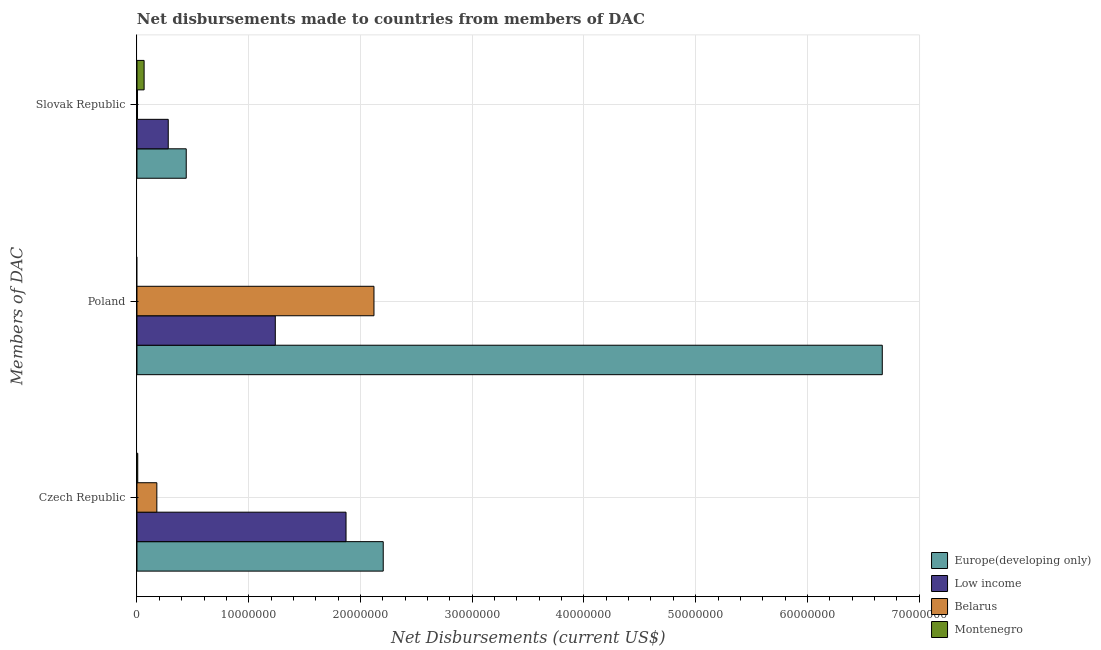How many different coloured bars are there?
Your answer should be compact. 4. Are the number of bars on each tick of the Y-axis equal?
Your answer should be very brief. No. How many bars are there on the 1st tick from the top?
Offer a terse response. 4. How many bars are there on the 3rd tick from the bottom?
Offer a very short reply. 4. What is the net disbursements made by slovak republic in Low income?
Offer a very short reply. 2.80e+06. Across all countries, what is the maximum net disbursements made by poland?
Your answer should be compact. 6.67e+07. In which country was the net disbursements made by poland maximum?
Your response must be concise. Europe(developing only). What is the total net disbursements made by poland in the graph?
Offer a very short reply. 1.00e+08. What is the difference between the net disbursements made by czech republic in Montenegro and that in Low income?
Your answer should be compact. -1.86e+07. What is the difference between the net disbursements made by slovak republic in Montenegro and the net disbursements made by poland in Europe(developing only)?
Make the answer very short. -6.61e+07. What is the average net disbursements made by slovak republic per country?
Give a very brief answer. 1.98e+06. What is the difference between the net disbursements made by poland and net disbursements made by czech republic in Belarus?
Keep it short and to the point. 1.94e+07. What is the ratio of the net disbursements made by slovak republic in Belarus to that in Europe(developing only)?
Ensure brevity in your answer.  0.01. Is the difference between the net disbursements made by czech republic in Low income and Europe(developing only) greater than the difference between the net disbursements made by poland in Low income and Europe(developing only)?
Your answer should be very brief. Yes. What is the difference between the highest and the second highest net disbursements made by slovak republic?
Make the answer very short. 1.61e+06. What is the difference between the highest and the lowest net disbursements made by poland?
Your response must be concise. 6.67e+07. Is it the case that in every country, the sum of the net disbursements made by czech republic and net disbursements made by poland is greater than the net disbursements made by slovak republic?
Your response must be concise. No. How many bars are there?
Make the answer very short. 11. Are all the bars in the graph horizontal?
Your response must be concise. Yes. Are the values on the major ticks of X-axis written in scientific E-notation?
Offer a terse response. No. Does the graph contain any zero values?
Provide a succinct answer. Yes. What is the title of the graph?
Make the answer very short. Net disbursements made to countries from members of DAC. Does "Cabo Verde" appear as one of the legend labels in the graph?
Provide a succinct answer. No. What is the label or title of the X-axis?
Keep it short and to the point. Net Disbursements (current US$). What is the label or title of the Y-axis?
Provide a succinct answer. Members of DAC. What is the Net Disbursements (current US$) in Europe(developing only) in Czech Republic?
Ensure brevity in your answer.  2.20e+07. What is the Net Disbursements (current US$) of Low income in Czech Republic?
Give a very brief answer. 1.87e+07. What is the Net Disbursements (current US$) of Belarus in Czech Republic?
Offer a terse response. 1.78e+06. What is the Net Disbursements (current US$) in Europe(developing only) in Poland?
Your answer should be very brief. 6.67e+07. What is the Net Disbursements (current US$) of Low income in Poland?
Provide a succinct answer. 1.24e+07. What is the Net Disbursements (current US$) of Belarus in Poland?
Your answer should be compact. 2.12e+07. What is the Net Disbursements (current US$) in Europe(developing only) in Slovak Republic?
Make the answer very short. 4.41e+06. What is the Net Disbursements (current US$) in Low income in Slovak Republic?
Ensure brevity in your answer.  2.80e+06. What is the Net Disbursements (current US$) in Belarus in Slovak Republic?
Ensure brevity in your answer.  5.00e+04. What is the Net Disbursements (current US$) in Montenegro in Slovak Republic?
Give a very brief answer. 6.40e+05. Across all Members of DAC, what is the maximum Net Disbursements (current US$) of Europe(developing only)?
Make the answer very short. 6.67e+07. Across all Members of DAC, what is the maximum Net Disbursements (current US$) in Low income?
Your response must be concise. 1.87e+07. Across all Members of DAC, what is the maximum Net Disbursements (current US$) of Belarus?
Offer a very short reply. 2.12e+07. Across all Members of DAC, what is the maximum Net Disbursements (current US$) of Montenegro?
Ensure brevity in your answer.  6.40e+05. Across all Members of DAC, what is the minimum Net Disbursements (current US$) of Europe(developing only)?
Provide a succinct answer. 4.41e+06. Across all Members of DAC, what is the minimum Net Disbursements (current US$) in Low income?
Offer a very short reply. 2.80e+06. Across all Members of DAC, what is the minimum Net Disbursements (current US$) in Montenegro?
Offer a terse response. 0. What is the total Net Disbursements (current US$) in Europe(developing only) in the graph?
Offer a very short reply. 9.32e+07. What is the total Net Disbursements (current US$) in Low income in the graph?
Your answer should be compact. 3.39e+07. What is the total Net Disbursements (current US$) in Belarus in the graph?
Your answer should be compact. 2.30e+07. What is the total Net Disbursements (current US$) in Montenegro in the graph?
Your answer should be very brief. 7.10e+05. What is the difference between the Net Disbursements (current US$) in Europe(developing only) in Czech Republic and that in Poland?
Provide a succinct answer. -4.47e+07. What is the difference between the Net Disbursements (current US$) in Low income in Czech Republic and that in Poland?
Offer a terse response. 6.33e+06. What is the difference between the Net Disbursements (current US$) of Belarus in Czech Republic and that in Poland?
Your answer should be compact. -1.94e+07. What is the difference between the Net Disbursements (current US$) in Europe(developing only) in Czech Republic and that in Slovak Republic?
Provide a succinct answer. 1.76e+07. What is the difference between the Net Disbursements (current US$) of Low income in Czech Republic and that in Slovak Republic?
Keep it short and to the point. 1.59e+07. What is the difference between the Net Disbursements (current US$) in Belarus in Czech Republic and that in Slovak Republic?
Your response must be concise. 1.73e+06. What is the difference between the Net Disbursements (current US$) of Montenegro in Czech Republic and that in Slovak Republic?
Your answer should be compact. -5.70e+05. What is the difference between the Net Disbursements (current US$) of Europe(developing only) in Poland and that in Slovak Republic?
Your answer should be compact. 6.23e+07. What is the difference between the Net Disbursements (current US$) of Low income in Poland and that in Slovak Republic?
Provide a short and direct response. 9.58e+06. What is the difference between the Net Disbursements (current US$) in Belarus in Poland and that in Slovak Republic?
Offer a very short reply. 2.12e+07. What is the difference between the Net Disbursements (current US$) in Europe(developing only) in Czech Republic and the Net Disbursements (current US$) in Low income in Poland?
Your answer should be compact. 9.66e+06. What is the difference between the Net Disbursements (current US$) in Europe(developing only) in Czech Republic and the Net Disbursements (current US$) in Belarus in Poland?
Provide a short and direct response. 8.30e+05. What is the difference between the Net Disbursements (current US$) in Low income in Czech Republic and the Net Disbursements (current US$) in Belarus in Poland?
Give a very brief answer. -2.50e+06. What is the difference between the Net Disbursements (current US$) of Europe(developing only) in Czech Republic and the Net Disbursements (current US$) of Low income in Slovak Republic?
Your answer should be compact. 1.92e+07. What is the difference between the Net Disbursements (current US$) in Europe(developing only) in Czech Republic and the Net Disbursements (current US$) in Belarus in Slovak Republic?
Give a very brief answer. 2.20e+07. What is the difference between the Net Disbursements (current US$) of Europe(developing only) in Czech Republic and the Net Disbursements (current US$) of Montenegro in Slovak Republic?
Your response must be concise. 2.14e+07. What is the difference between the Net Disbursements (current US$) in Low income in Czech Republic and the Net Disbursements (current US$) in Belarus in Slovak Republic?
Offer a terse response. 1.87e+07. What is the difference between the Net Disbursements (current US$) in Low income in Czech Republic and the Net Disbursements (current US$) in Montenegro in Slovak Republic?
Give a very brief answer. 1.81e+07. What is the difference between the Net Disbursements (current US$) in Belarus in Czech Republic and the Net Disbursements (current US$) in Montenegro in Slovak Republic?
Offer a terse response. 1.14e+06. What is the difference between the Net Disbursements (current US$) of Europe(developing only) in Poland and the Net Disbursements (current US$) of Low income in Slovak Republic?
Ensure brevity in your answer.  6.39e+07. What is the difference between the Net Disbursements (current US$) in Europe(developing only) in Poland and the Net Disbursements (current US$) in Belarus in Slovak Republic?
Your answer should be very brief. 6.66e+07. What is the difference between the Net Disbursements (current US$) of Europe(developing only) in Poland and the Net Disbursements (current US$) of Montenegro in Slovak Republic?
Provide a short and direct response. 6.61e+07. What is the difference between the Net Disbursements (current US$) in Low income in Poland and the Net Disbursements (current US$) in Belarus in Slovak Republic?
Offer a very short reply. 1.23e+07. What is the difference between the Net Disbursements (current US$) in Low income in Poland and the Net Disbursements (current US$) in Montenegro in Slovak Republic?
Ensure brevity in your answer.  1.17e+07. What is the difference between the Net Disbursements (current US$) of Belarus in Poland and the Net Disbursements (current US$) of Montenegro in Slovak Republic?
Make the answer very short. 2.06e+07. What is the average Net Disbursements (current US$) in Europe(developing only) per Members of DAC?
Keep it short and to the point. 3.10e+07. What is the average Net Disbursements (current US$) of Low income per Members of DAC?
Your answer should be very brief. 1.13e+07. What is the average Net Disbursements (current US$) of Belarus per Members of DAC?
Keep it short and to the point. 7.68e+06. What is the average Net Disbursements (current US$) of Montenegro per Members of DAC?
Offer a terse response. 2.37e+05. What is the difference between the Net Disbursements (current US$) in Europe(developing only) and Net Disbursements (current US$) in Low income in Czech Republic?
Ensure brevity in your answer.  3.33e+06. What is the difference between the Net Disbursements (current US$) of Europe(developing only) and Net Disbursements (current US$) of Belarus in Czech Republic?
Offer a very short reply. 2.03e+07. What is the difference between the Net Disbursements (current US$) of Europe(developing only) and Net Disbursements (current US$) of Montenegro in Czech Republic?
Provide a short and direct response. 2.20e+07. What is the difference between the Net Disbursements (current US$) in Low income and Net Disbursements (current US$) in Belarus in Czech Republic?
Your answer should be compact. 1.69e+07. What is the difference between the Net Disbursements (current US$) of Low income and Net Disbursements (current US$) of Montenegro in Czech Republic?
Offer a very short reply. 1.86e+07. What is the difference between the Net Disbursements (current US$) of Belarus and Net Disbursements (current US$) of Montenegro in Czech Republic?
Provide a succinct answer. 1.71e+06. What is the difference between the Net Disbursements (current US$) of Europe(developing only) and Net Disbursements (current US$) of Low income in Poland?
Ensure brevity in your answer.  5.43e+07. What is the difference between the Net Disbursements (current US$) of Europe(developing only) and Net Disbursements (current US$) of Belarus in Poland?
Give a very brief answer. 4.55e+07. What is the difference between the Net Disbursements (current US$) in Low income and Net Disbursements (current US$) in Belarus in Poland?
Your response must be concise. -8.83e+06. What is the difference between the Net Disbursements (current US$) of Europe(developing only) and Net Disbursements (current US$) of Low income in Slovak Republic?
Provide a succinct answer. 1.61e+06. What is the difference between the Net Disbursements (current US$) of Europe(developing only) and Net Disbursements (current US$) of Belarus in Slovak Republic?
Provide a succinct answer. 4.36e+06. What is the difference between the Net Disbursements (current US$) of Europe(developing only) and Net Disbursements (current US$) of Montenegro in Slovak Republic?
Offer a terse response. 3.77e+06. What is the difference between the Net Disbursements (current US$) of Low income and Net Disbursements (current US$) of Belarus in Slovak Republic?
Make the answer very short. 2.75e+06. What is the difference between the Net Disbursements (current US$) in Low income and Net Disbursements (current US$) in Montenegro in Slovak Republic?
Offer a terse response. 2.16e+06. What is the difference between the Net Disbursements (current US$) of Belarus and Net Disbursements (current US$) of Montenegro in Slovak Republic?
Provide a succinct answer. -5.90e+05. What is the ratio of the Net Disbursements (current US$) of Europe(developing only) in Czech Republic to that in Poland?
Make the answer very short. 0.33. What is the ratio of the Net Disbursements (current US$) in Low income in Czech Republic to that in Poland?
Provide a short and direct response. 1.51. What is the ratio of the Net Disbursements (current US$) in Belarus in Czech Republic to that in Poland?
Offer a terse response. 0.08. What is the ratio of the Net Disbursements (current US$) of Europe(developing only) in Czech Republic to that in Slovak Republic?
Make the answer very short. 5. What is the ratio of the Net Disbursements (current US$) in Low income in Czech Republic to that in Slovak Republic?
Give a very brief answer. 6.68. What is the ratio of the Net Disbursements (current US$) in Belarus in Czech Republic to that in Slovak Republic?
Your answer should be very brief. 35.6. What is the ratio of the Net Disbursements (current US$) in Montenegro in Czech Republic to that in Slovak Republic?
Your answer should be compact. 0.11. What is the ratio of the Net Disbursements (current US$) in Europe(developing only) in Poland to that in Slovak Republic?
Keep it short and to the point. 15.12. What is the ratio of the Net Disbursements (current US$) in Low income in Poland to that in Slovak Republic?
Keep it short and to the point. 4.42. What is the ratio of the Net Disbursements (current US$) in Belarus in Poland to that in Slovak Republic?
Offer a very short reply. 424.2. What is the difference between the highest and the second highest Net Disbursements (current US$) of Europe(developing only)?
Provide a short and direct response. 4.47e+07. What is the difference between the highest and the second highest Net Disbursements (current US$) of Low income?
Your response must be concise. 6.33e+06. What is the difference between the highest and the second highest Net Disbursements (current US$) of Belarus?
Provide a succinct answer. 1.94e+07. What is the difference between the highest and the lowest Net Disbursements (current US$) in Europe(developing only)?
Keep it short and to the point. 6.23e+07. What is the difference between the highest and the lowest Net Disbursements (current US$) of Low income?
Your response must be concise. 1.59e+07. What is the difference between the highest and the lowest Net Disbursements (current US$) in Belarus?
Give a very brief answer. 2.12e+07. What is the difference between the highest and the lowest Net Disbursements (current US$) in Montenegro?
Offer a terse response. 6.40e+05. 